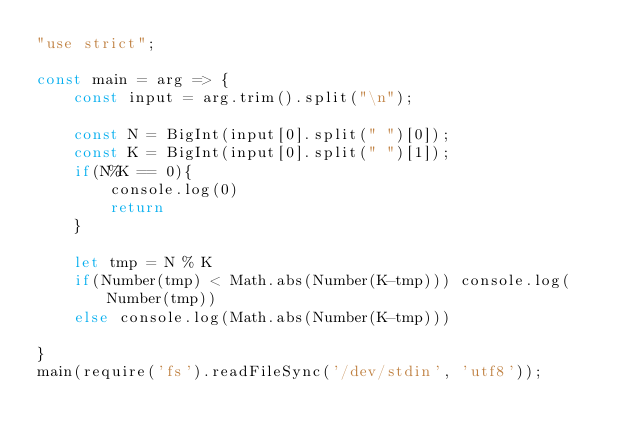<code> <loc_0><loc_0><loc_500><loc_500><_JavaScript_>"use strict";

const main = arg => {
    const input = arg.trim().split("\n");

    const N = BigInt(input[0].split(" ")[0]);
    const K = BigInt(input[0].split(" ")[1]);
    if(N%K == 0){
        console.log(0)
        return
    } 

    let tmp = N % K
    if(Number(tmp) < Math.abs(Number(K-tmp))) console.log(Number(tmp))
    else console.log(Math.abs(Number(K-tmp)))

}
main(require('fs').readFileSync('/dev/stdin', 'utf8'));
</code> 